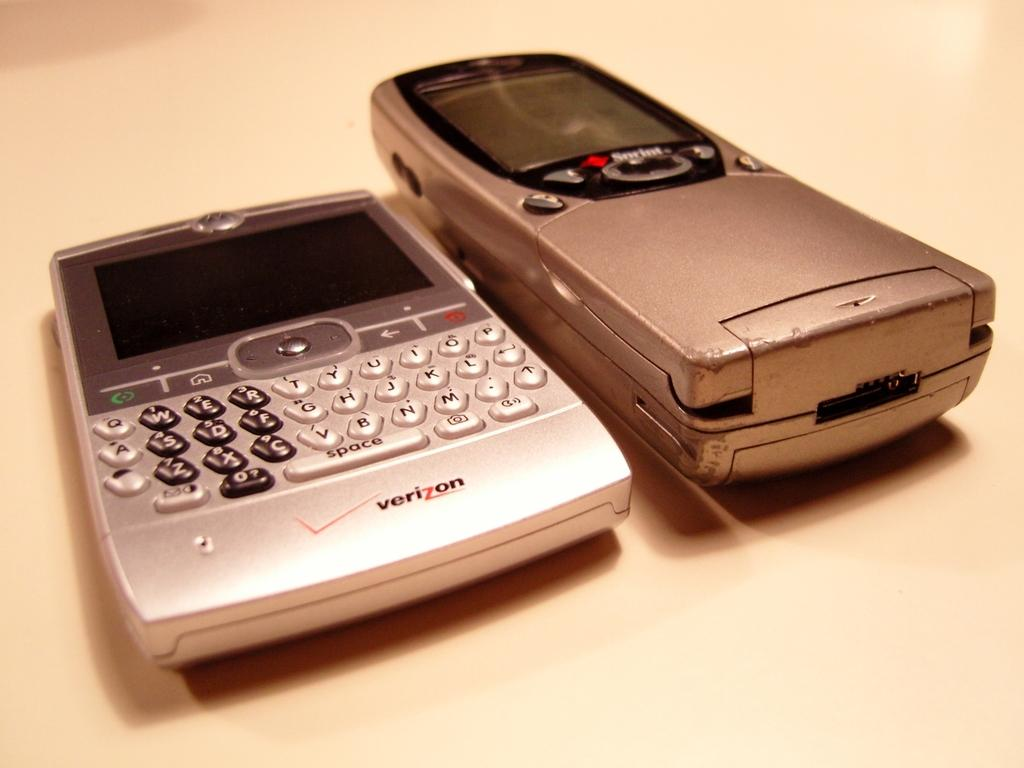<image>
Present a compact description of the photo's key features. A verizon device sitting next to a sprint device. 